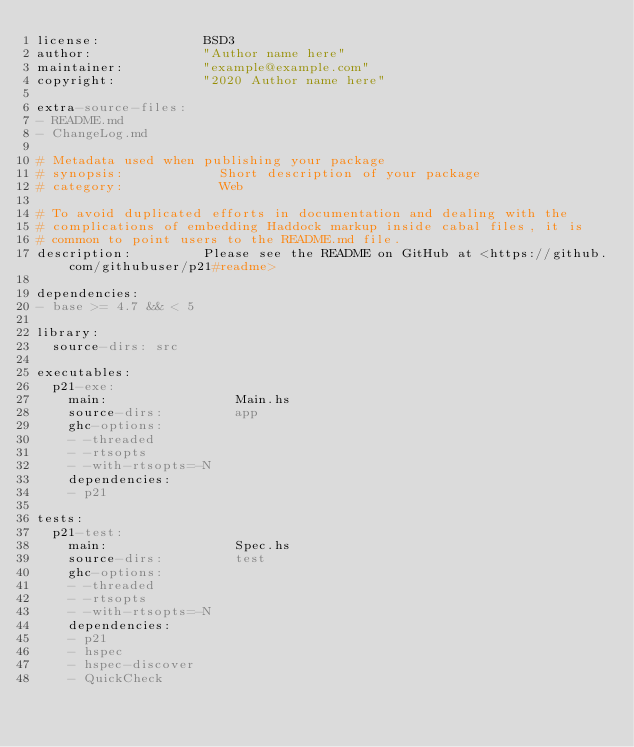<code> <loc_0><loc_0><loc_500><loc_500><_YAML_>license:             BSD3
author:              "Author name here"
maintainer:          "example@example.com"
copyright:           "2020 Author name here"

extra-source-files:
- README.md
- ChangeLog.md

# Metadata used when publishing your package
# synopsis:            Short description of your package
# category:            Web

# To avoid duplicated efforts in documentation and dealing with the
# complications of embedding Haddock markup inside cabal files, it is
# common to point users to the README.md file.
description:         Please see the README on GitHub at <https://github.com/githubuser/p21#readme>

dependencies:
- base >= 4.7 && < 5

library:
  source-dirs: src

executables:
  p21-exe:
    main:                Main.hs
    source-dirs:         app
    ghc-options:
    - -threaded
    - -rtsopts
    - -with-rtsopts=-N
    dependencies:
    - p21

tests:
  p21-test:
    main:                Spec.hs
    source-dirs:         test
    ghc-options:
    - -threaded
    - -rtsopts
    - -with-rtsopts=-N
    dependencies:
    - p21
    - hspec
    - hspec-discover
    - QuickCheck
</code> 